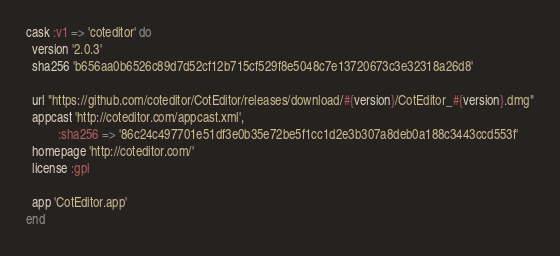<code> <loc_0><loc_0><loc_500><loc_500><_Ruby_>cask :v1 => 'coteditor' do
  version '2.0.3'
  sha256 'b656aa0b6526c89d7d52cf12b715cf529f8e5048c7e13720673c3e32318a26d8'

  url "https://github.com/coteditor/CotEditor/releases/download/#{version}/CotEditor_#{version}.dmg"
  appcast 'http://coteditor.com/appcast.xml',
          :sha256 => '86c24c497701e51df3e0b35e72be5f1cc1d2e3b307a8deb0a188c3443ccd553f'
  homepage 'http://coteditor.com/'
  license :gpl

  app 'CotEditor.app'
end
</code> 